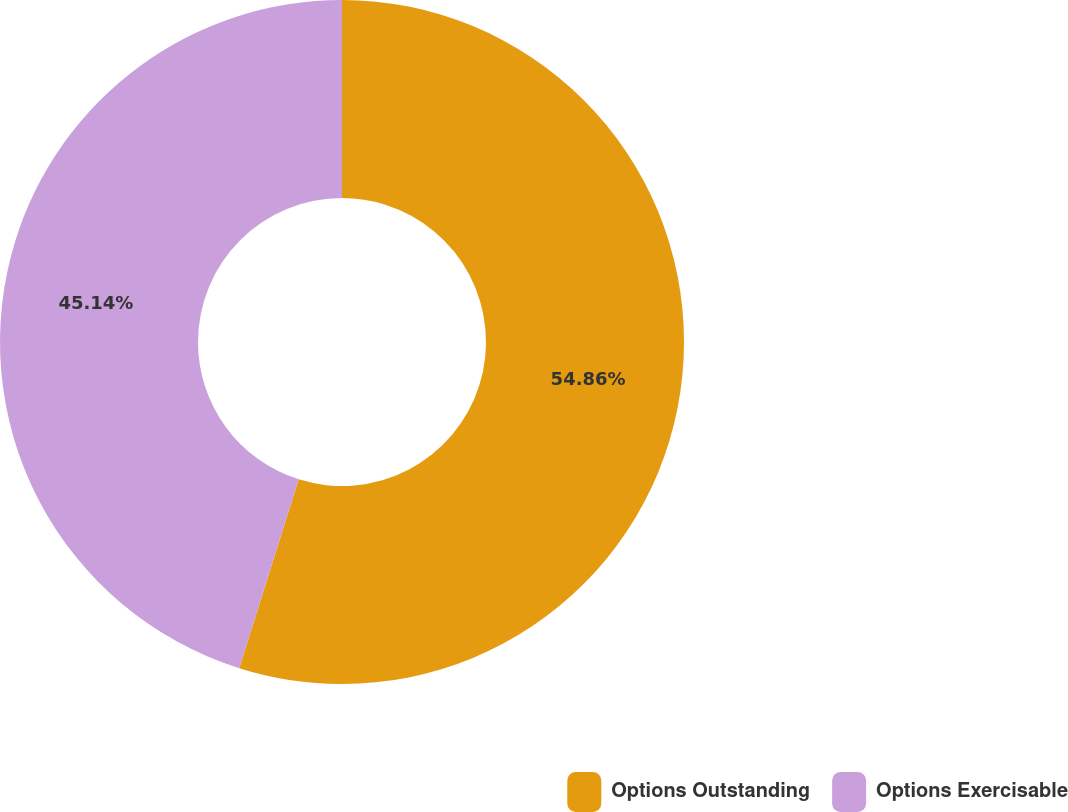<chart> <loc_0><loc_0><loc_500><loc_500><pie_chart><fcel>Options Outstanding<fcel>Options Exercisable<nl><fcel>54.86%<fcel>45.14%<nl></chart> 